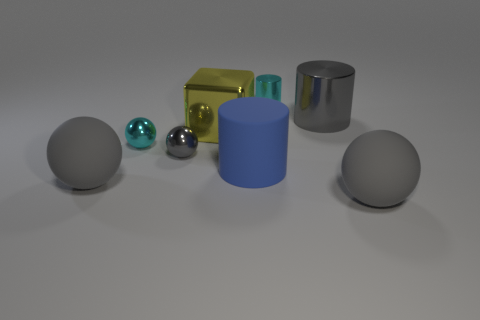Are there any other tiny purple blocks made of the same material as the cube?
Ensure brevity in your answer.  No. Are there the same number of large blocks on the left side of the tiny cyan sphere and gray rubber spheres left of the metallic block?
Your answer should be compact. No. There is a gray matte object left of the big metal cylinder; how big is it?
Your response must be concise. Large. What is the yellow thing to the left of the gray sphere on the right side of the large yellow metal object made of?
Keep it short and to the point. Metal. There is a cyan object that is behind the cyan object that is in front of the tiny cylinder; how many gray metal balls are behind it?
Give a very brief answer. 0. Does the large object that is left of the big shiny block have the same material as the sphere on the right side of the gray shiny sphere?
Make the answer very short. Yes. There is a object that is the same color as the tiny cylinder; what is its material?
Your answer should be compact. Metal. What number of other tiny gray objects are the same shape as the tiny gray shiny thing?
Make the answer very short. 0. Are there more gray objects to the left of the big metallic cylinder than tiny purple shiny spheres?
Offer a terse response. Yes. What shape is the object that is in front of the rubber sphere on the left side of the big yellow thing behind the blue cylinder?
Keep it short and to the point. Sphere. 